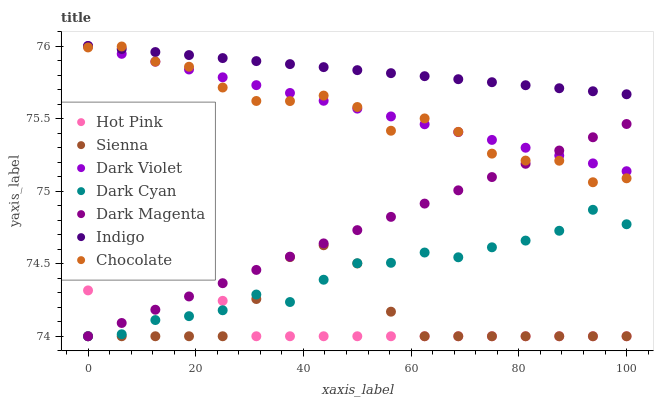Does Hot Pink have the minimum area under the curve?
Answer yes or no. Yes. Does Indigo have the maximum area under the curve?
Answer yes or no. Yes. Does Dark Magenta have the minimum area under the curve?
Answer yes or no. No. Does Dark Magenta have the maximum area under the curve?
Answer yes or no. No. Is Dark Magenta the smoothest?
Answer yes or no. Yes. Is Chocolate the roughest?
Answer yes or no. Yes. Is Hot Pink the smoothest?
Answer yes or no. No. Is Hot Pink the roughest?
Answer yes or no. No. Does Dark Magenta have the lowest value?
Answer yes or no. Yes. Does Dark Violet have the lowest value?
Answer yes or no. No. Does Dark Violet have the highest value?
Answer yes or no. Yes. Does Dark Magenta have the highest value?
Answer yes or no. No. Is Sienna less than Indigo?
Answer yes or no. Yes. Is Indigo greater than Hot Pink?
Answer yes or no. Yes. Does Chocolate intersect Dark Violet?
Answer yes or no. Yes. Is Chocolate less than Dark Violet?
Answer yes or no. No. Is Chocolate greater than Dark Violet?
Answer yes or no. No. Does Sienna intersect Indigo?
Answer yes or no. No. 